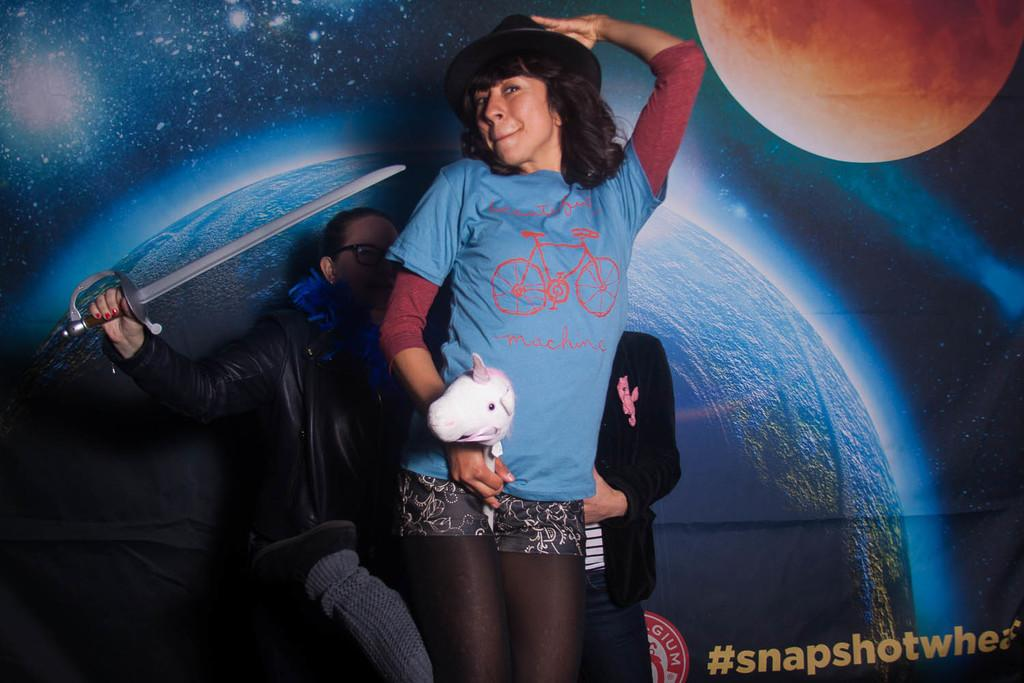How many people are in the image? There are three persons in the image. What is the person in the middle holding? The person in the middle is holding a toy. What is the person on the left side holding? The person on the left side is holding a sword. What can be seen in the background of the image? There is a wall poster in the background of the image. What type of tooth is visible in the image? There is no tooth visible in the image. Are there any fairies present in the image? There are no fairies present in the image. 